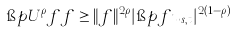Convert formula to latex. <formula><loc_0><loc_0><loc_500><loc_500>\i p { U ^ { \rho } f } { f } \geq \| f \| ^ { 2 \rho } | \i p { f } { u _ { s , t } } | ^ { 2 ( 1 - \rho ) }</formula> 